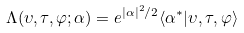Convert formula to latex. <formula><loc_0><loc_0><loc_500><loc_500>\Lambda ( \upsilon , \tau , \varphi ; \alpha ) = e ^ { | \alpha | ^ { 2 } / 2 } \langle \alpha ^ { \ast } | \upsilon , \tau , \varphi \rangle</formula> 